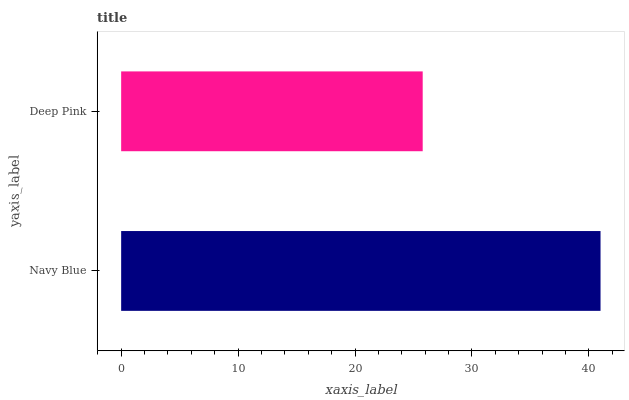Is Deep Pink the minimum?
Answer yes or no. Yes. Is Navy Blue the maximum?
Answer yes or no. Yes. Is Deep Pink the maximum?
Answer yes or no. No. Is Navy Blue greater than Deep Pink?
Answer yes or no. Yes. Is Deep Pink less than Navy Blue?
Answer yes or no. Yes. Is Deep Pink greater than Navy Blue?
Answer yes or no. No. Is Navy Blue less than Deep Pink?
Answer yes or no. No. Is Navy Blue the high median?
Answer yes or no. Yes. Is Deep Pink the low median?
Answer yes or no. Yes. Is Deep Pink the high median?
Answer yes or no. No. Is Navy Blue the low median?
Answer yes or no. No. 